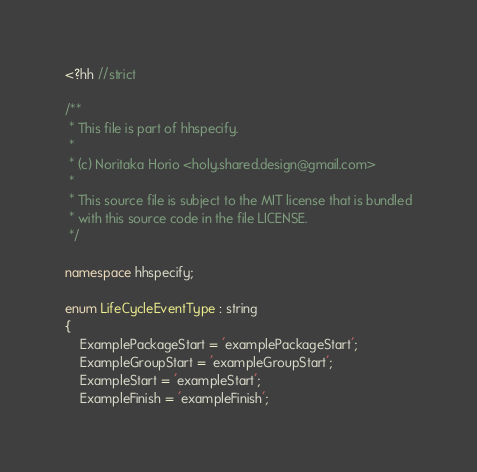<code> <loc_0><loc_0><loc_500><loc_500><_C++_><?hh //strict

/**
 * This file is part of hhspecify.
 *
 * (c) Noritaka Horio <holy.shared.design@gmail.com>
 *
 * This source file is subject to the MIT license that is bundled
 * with this source code in the file LICENSE.
 */

namespace hhspecify;

enum LifeCycleEventType : string
{
    ExamplePackageStart = 'examplePackageStart';
    ExampleGroupStart = 'exampleGroupStart';
    ExampleStart = 'exampleStart';
    ExampleFinish = 'exampleFinish';</code> 